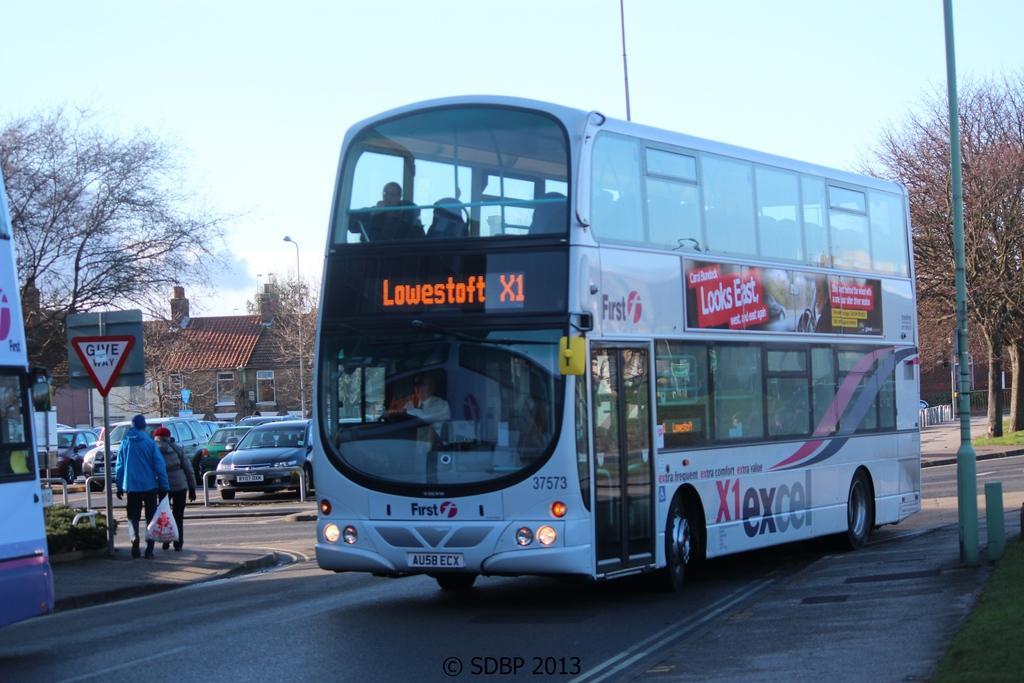Please provide a concise description of this image. In this picture there are buses on the road and there are group of people sitting inside the bus. At the back there are two persons walking on the footpath. At the back there are vehicles, buildings, trees and poles. At the top there is sky. At the bottom there is a road and there is grass. 